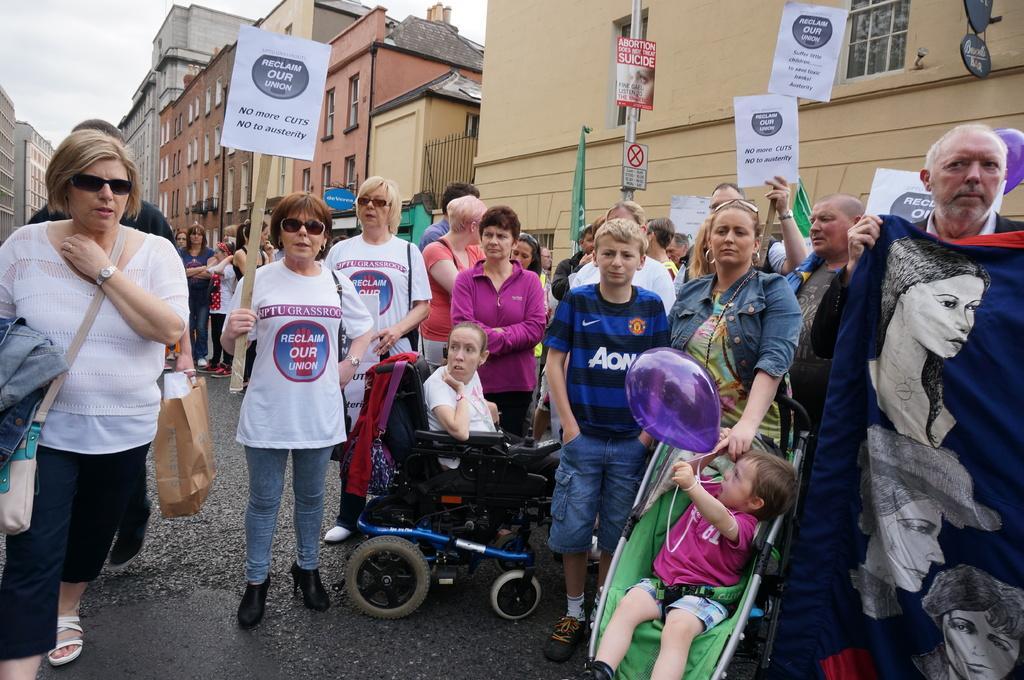Could you give a brief overview of what you see in this image? In the image we can see there are many people around, they are wearing clothes, some of them are wearing shoes and slippers. This is a balloon, baby wheel, buildings, poster, pole, windows of the building, road, paper bag, hand bag, wrist watch, goggle, earrings and a sky. 